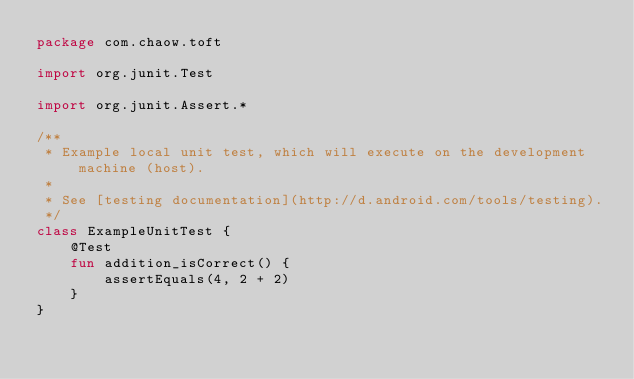<code> <loc_0><loc_0><loc_500><loc_500><_Kotlin_>package com.chaow.toft

import org.junit.Test

import org.junit.Assert.*

/**
 * Example local unit test, which will execute on the development machine (host).
 *
 * See [testing documentation](http://d.android.com/tools/testing).
 */
class ExampleUnitTest {
    @Test
    fun addition_isCorrect() {
        assertEquals(4, 2 + 2)
    }
}
</code> 